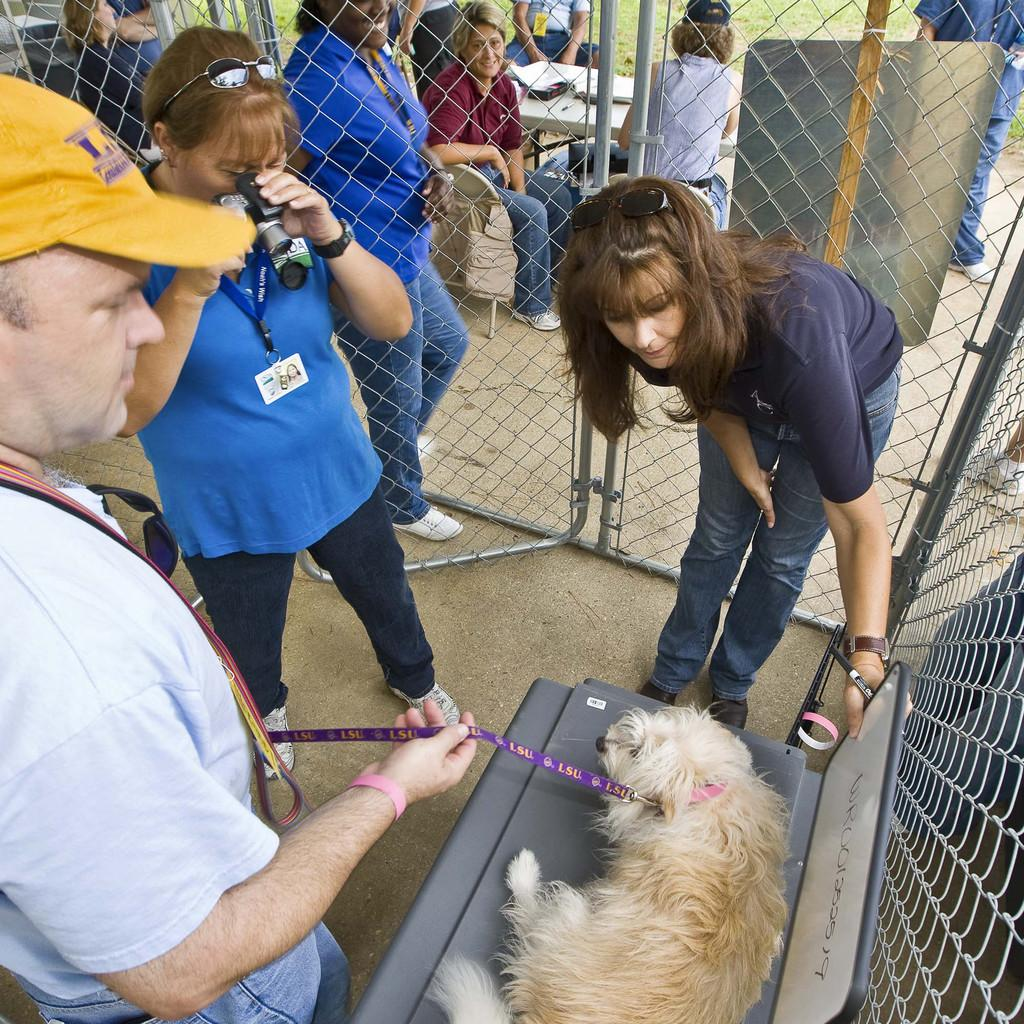How many people are in the image? There are three people in the image. What are the people doing in the image? The people are standing around a chair. What is on the chair in the image? There is a dog on the chair. What type of planes can be seen flying in the image? There are no planes visible in the image. What color is the cloud in the image? There is no cloud present in the image. 